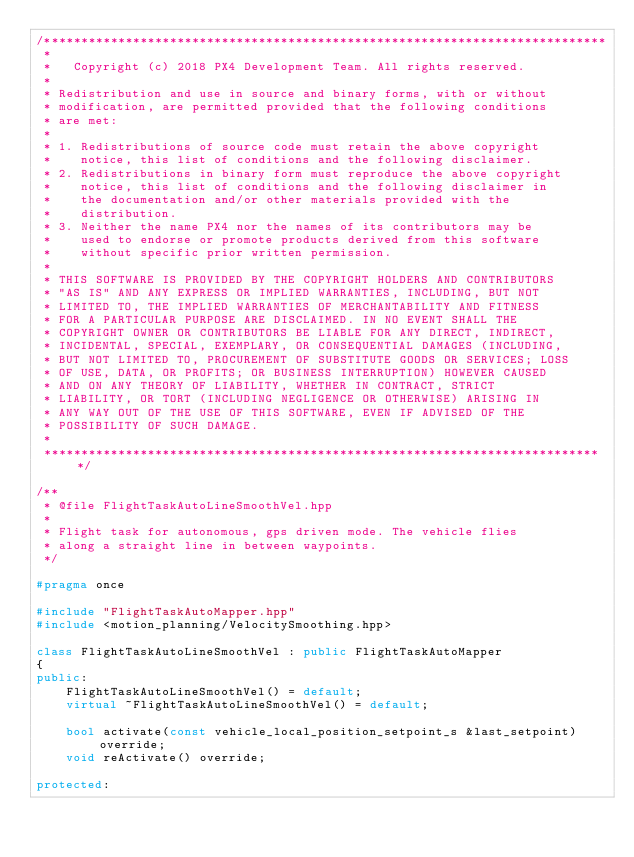Convert code to text. <code><loc_0><loc_0><loc_500><loc_500><_C++_>/****************************************************************************
 *
 *   Copyright (c) 2018 PX4 Development Team. All rights reserved.
 *
 * Redistribution and use in source and binary forms, with or without
 * modification, are permitted provided that the following conditions
 * are met:
 *
 * 1. Redistributions of source code must retain the above copyright
 *    notice, this list of conditions and the following disclaimer.
 * 2. Redistributions in binary form must reproduce the above copyright
 *    notice, this list of conditions and the following disclaimer in
 *    the documentation and/or other materials provided with the
 *    distribution.
 * 3. Neither the name PX4 nor the names of its contributors may be
 *    used to endorse or promote products derived from this software
 *    without specific prior written permission.
 *
 * THIS SOFTWARE IS PROVIDED BY THE COPYRIGHT HOLDERS AND CONTRIBUTORS
 * "AS IS" AND ANY EXPRESS OR IMPLIED WARRANTIES, INCLUDING, BUT NOT
 * LIMITED TO, THE IMPLIED WARRANTIES OF MERCHANTABILITY AND FITNESS
 * FOR A PARTICULAR PURPOSE ARE DISCLAIMED. IN NO EVENT SHALL THE
 * COPYRIGHT OWNER OR CONTRIBUTORS BE LIABLE FOR ANY DIRECT, INDIRECT,
 * INCIDENTAL, SPECIAL, EXEMPLARY, OR CONSEQUENTIAL DAMAGES (INCLUDING,
 * BUT NOT LIMITED TO, PROCUREMENT OF SUBSTITUTE GOODS OR SERVICES; LOSS
 * OF USE, DATA, OR PROFITS; OR BUSINESS INTERRUPTION) HOWEVER CAUSED
 * AND ON ANY THEORY OF LIABILITY, WHETHER IN CONTRACT, STRICT
 * LIABILITY, OR TORT (INCLUDING NEGLIGENCE OR OTHERWISE) ARISING IN
 * ANY WAY OUT OF THE USE OF THIS SOFTWARE, EVEN IF ADVISED OF THE
 * POSSIBILITY OF SUCH DAMAGE.
 *
 ****************************************************************************/

/**
 * @file FlightTaskAutoLineSmoothVel.hpp
 *
 * Flight task for autonomous, gps driven mode. The vehicle flies
 * along a straight line in between waypoints.
 */

#pragma once

#include "FlightTaskAutoMapper.hpp"
#include <motion_planning/VelocitySmoothing.hpp>

class FlightTaskAutoLineSmoothVel : public FlightTaskAutoMapper
{
public:
	FlightTaskAutoLineSmoothVel() = default;
	virtual ~FlightTaskAutoLineSmoothVel() = default;

	bool activate(const vehicle_local_position_setpoint_s &last_setpoint) override;
	void reActivate() override;

protected:
</code> 